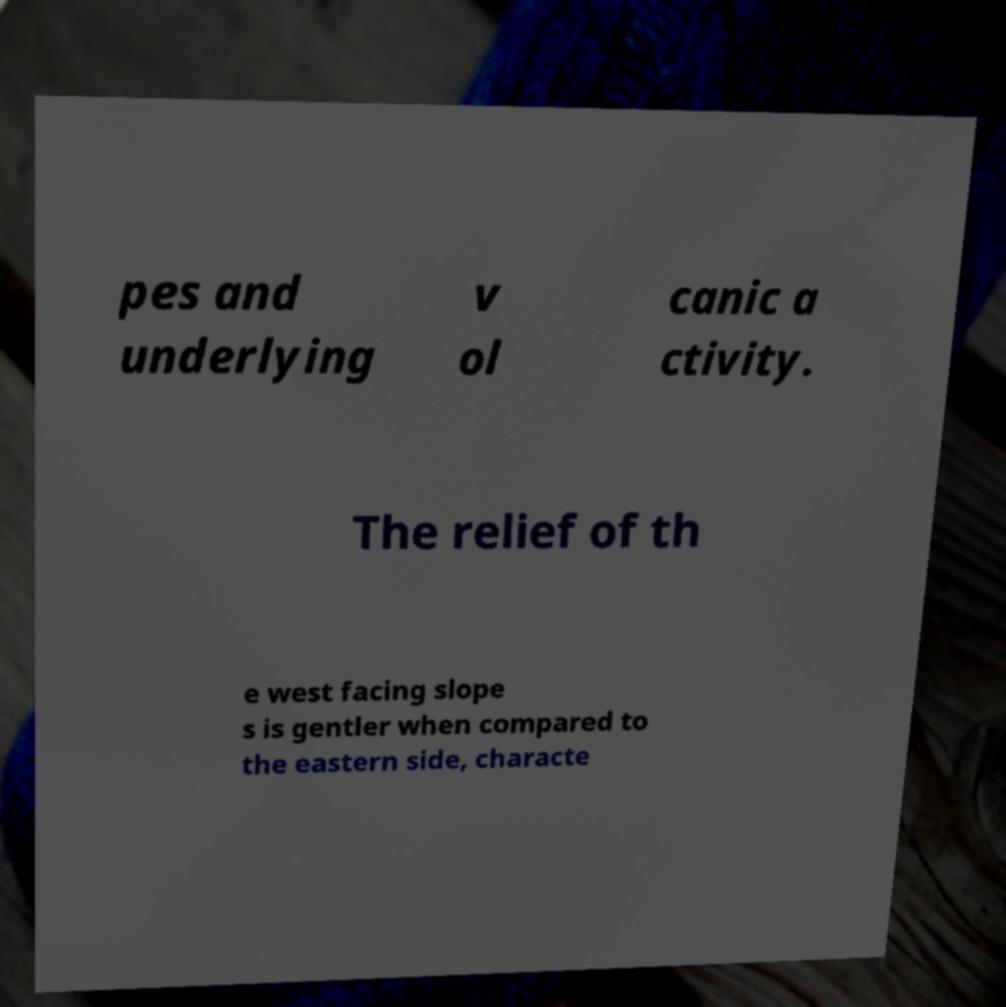Please identify and transcribe the text found in this image. pes and underlying v ol canic a ctivity. The relief of th e west facing slope s is gentler when compared to the eastern side, characte 